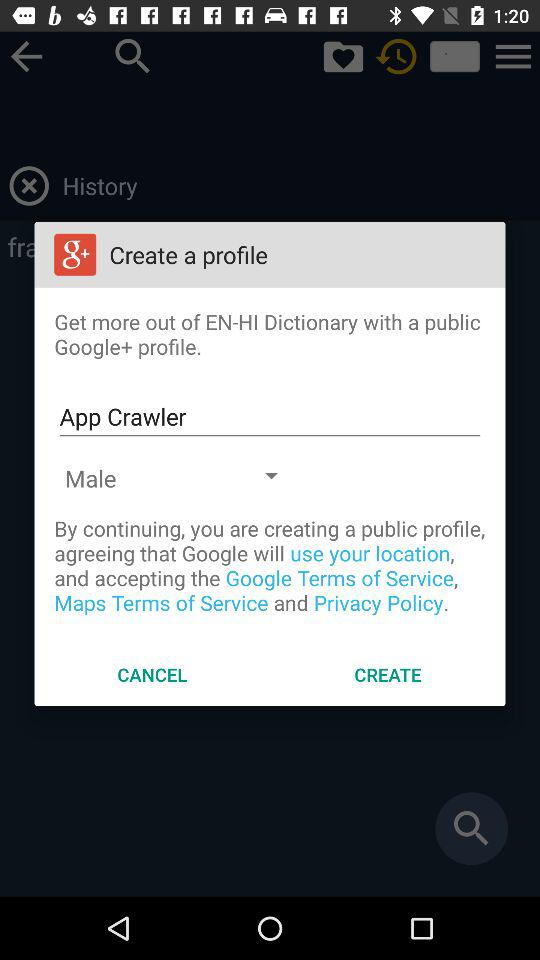What is the given profile name? The given profile name is App Crawler. 